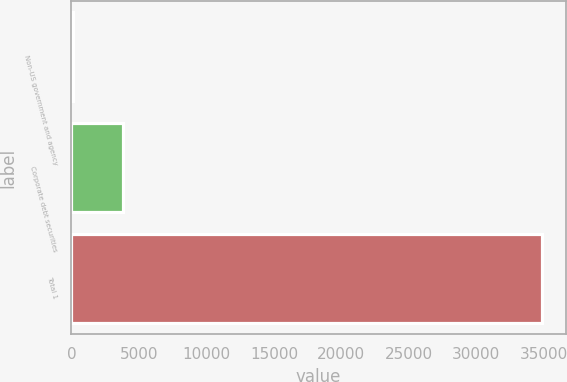<chart> <loc_0><loc_0><loc_500><loc_500><bar_chart><fcel>Non-US government and agency<fcel>Corporate debt securities<fcel>Total 1<nl><fcel>136<fcel>3815<fcel>34875<nl></chart> 